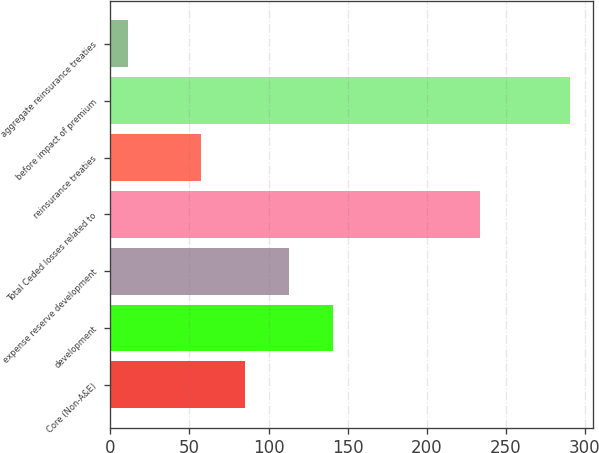Convert chart. <chart><loc_0><loc_0><loc_500><loc_500><bar_chart><fcel>Core (Non-A&E)<fcel>development<fcel>expense reserve development<fcel>Total Ceded losses related to<fcel>reinsurance treaties<fcel>before impact of premium<fcel>aggregate reinsurance treaties<nl><fcel>85<fcel>141<fcel>113<fcel>234<fcel>57<fcel>291<fcel>11<nl></chart> 